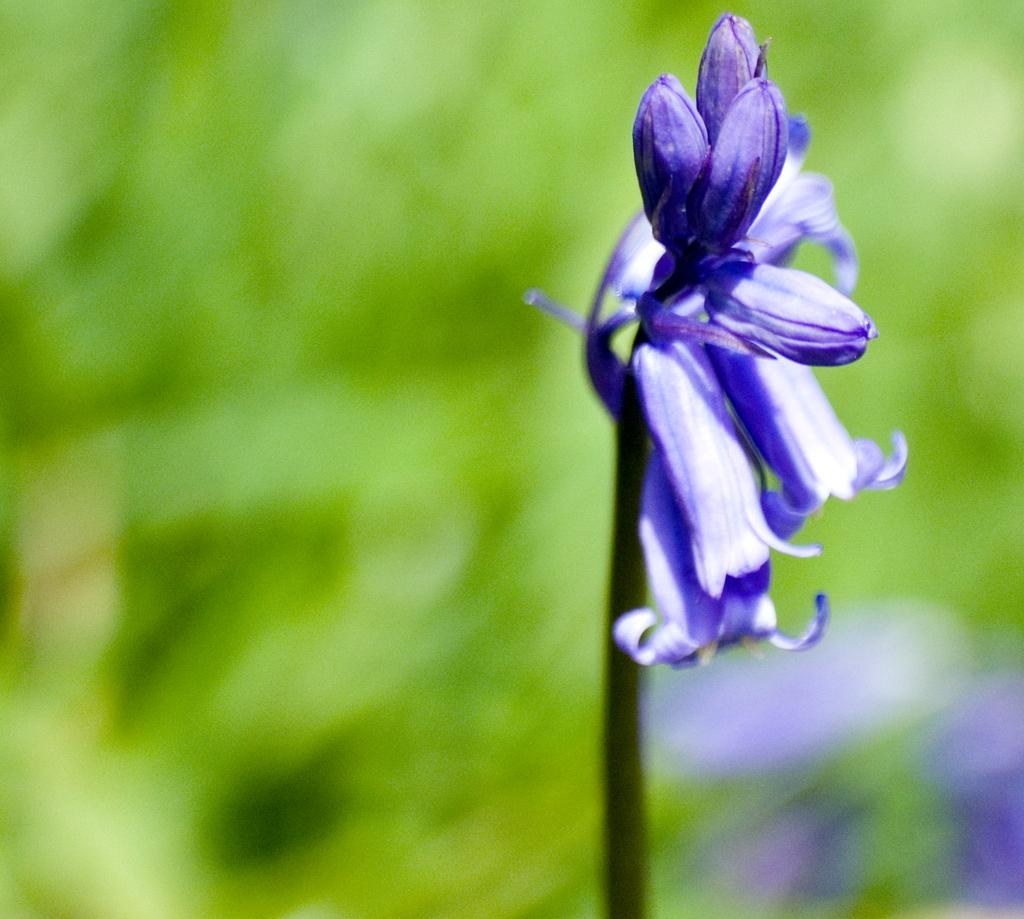What type of living organisms can be seen in the image? Flowers are visible in the image. Can you tell me how many bees are playing the guitar on the quartz in the image? There are no bees, guitars, or quartz present in the image; it features flowers only. 